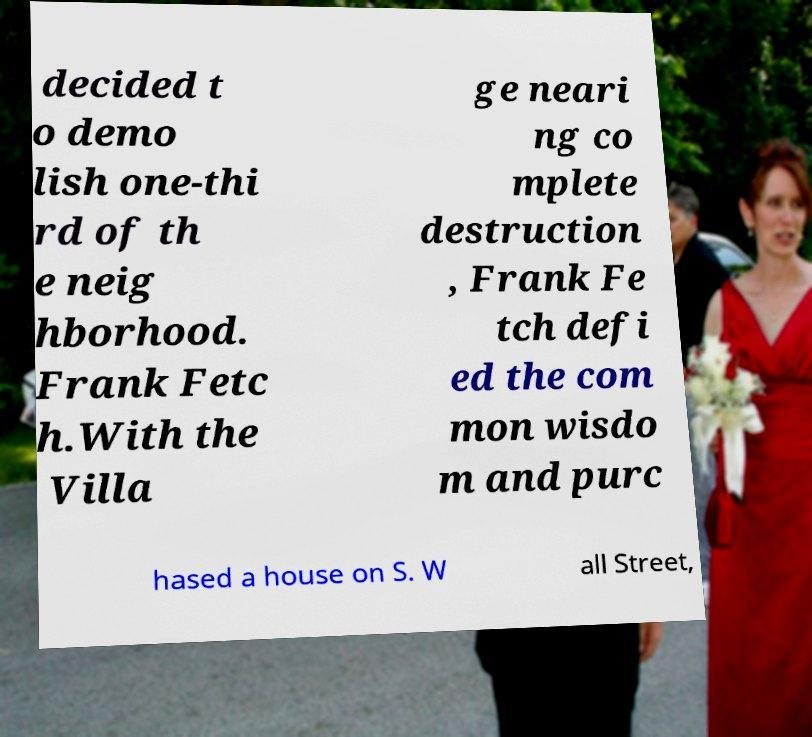Please identify and transcribe the text found in this image. decided t o demo lish one-thi rd of th e neig hborhood. Frank Fetc h.With the Villa ge neari ng co mplete destruction , Frank Fe tch defi ed the com mon wisdo m and purc hased a house on S. W all Street, 